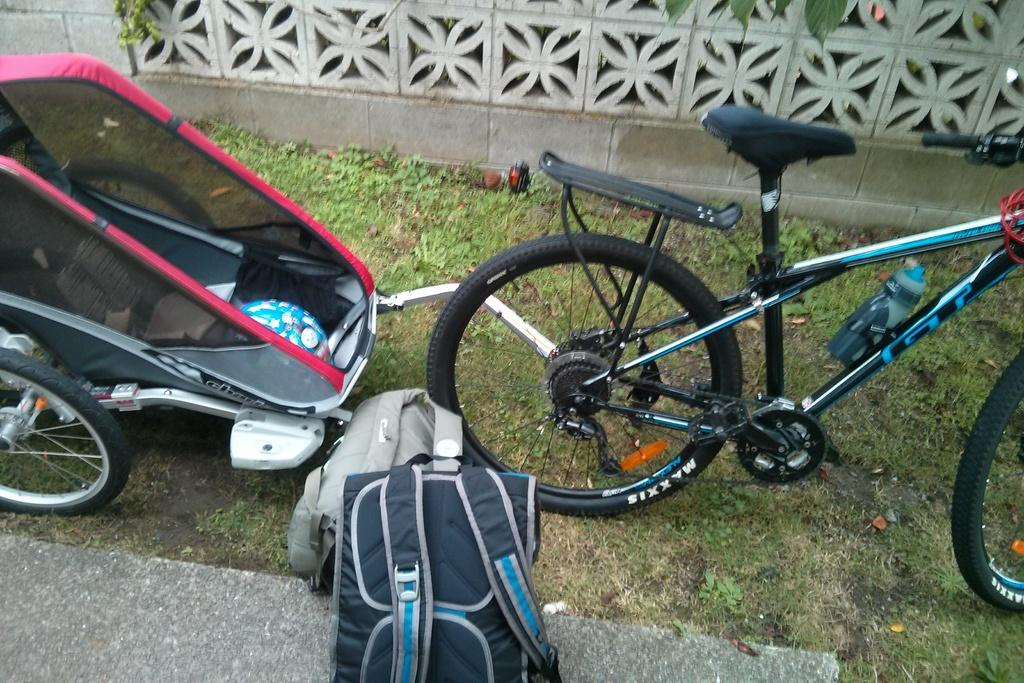What type of vehicle is present in the image? There is a bicycle in the image. What other item can be seen in the image that is used for transporting children? There is a stroller in the image. What items are on the floor in the image? There are backpacks on the floor in the image. What can be seen in the background of the image? There is a wall visible in the image. What type of terrain is visible in the image? There is grass on the ground in the image. Where is the hospital located in the image? There is no hospital present in the image. What type of play equipment can be seen in the image? There is no play equipment present in the image. 